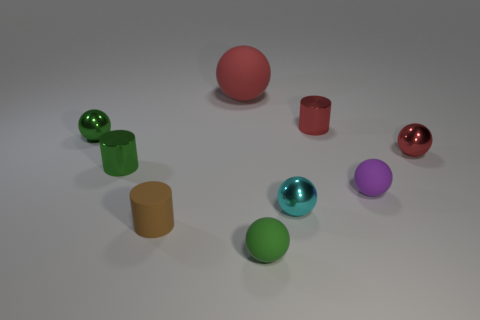Is there anything else that has the same size as the red matte ball?
Keep it short and to the point. No. Is there anything else that is the same shape as the brown thing?
Provide a succinct answer. Yes. Is the green sphere that is in front of the matte cylinder made of the same material as the small cylinder that is right of the large red thing?
Offer a very short reply. No. What is the small cyan ball made of?
Give a very brief answer. Metal. What number of large gray cylinders are the same material as the tiny brown object?
Offer a very short reply. 0. How many rubber things are either tiny cyan things or yellow cylinders?
Your answer should be very brief. 0. Do the tiny red metallic thing left of the small purple object and the rubber object in front of the brown cylinder have the same shape?
Provide a short and direct response. No. The rubber thing that is both left of the purple matte ball and behind the tiny brown rubber cylinder is what color?
Keep it short and to the point. Red. Does the green metal object in front of the red metallic ball have the same size as the rubber object in front of the brown matte cylinder?
Offer a terse response. Yes. What number of other large matte objects are the same color as the big matte object?
Offer a very short reply. 0. 